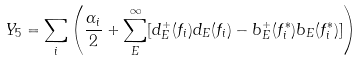<formula> <loc_0><loc_0><loc_500><loc_500>Y _ { 5 } = \sum _ { i } \left ( \frac { \alpha _ { i } } { 2 } + \sum _ { E } ^ { \infty } [ d ^ { + } _ { E } ( f _ { i } ) d _ { E } ( f _ { i } ) - b ^ { + } _ { E } ( f _ { i } ^ { \ast } ) b _ { E } ( f _ { i } ^ { \ast } ) ] \right )</formula> 